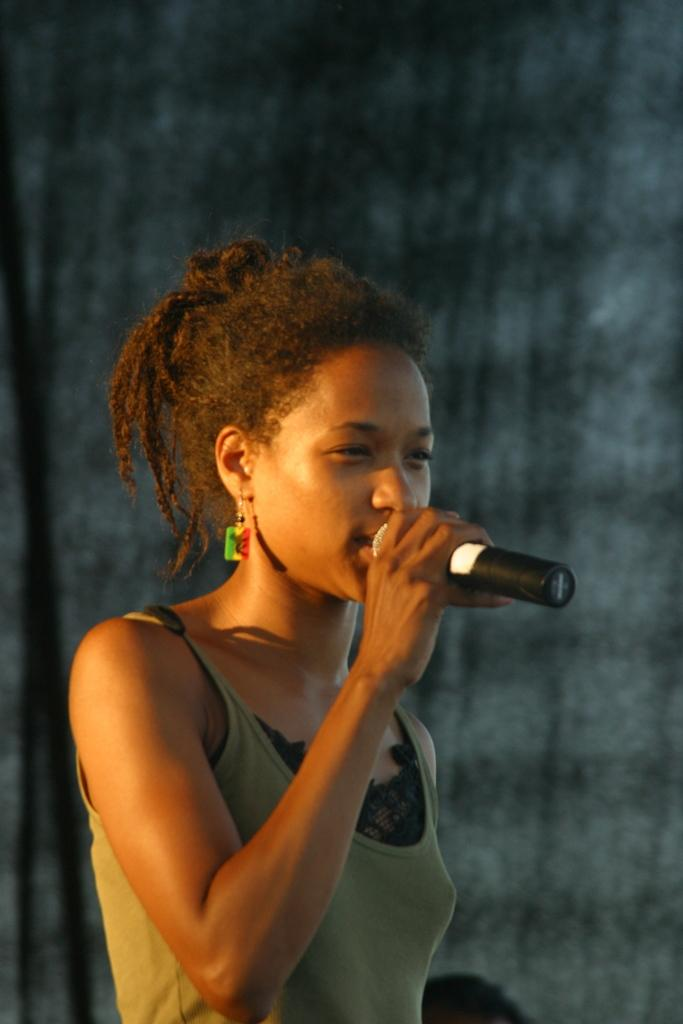Who is the main subject in the picture? There is a woman in the picture. What is the woman doing in the image? The woman is standing and singing. What object is the woman holding in her hand? The woman is holding a microphone in her hand. What time of day is it in the image? There is no indication of time in the image, and the provided facts do not mention any time-related information. 